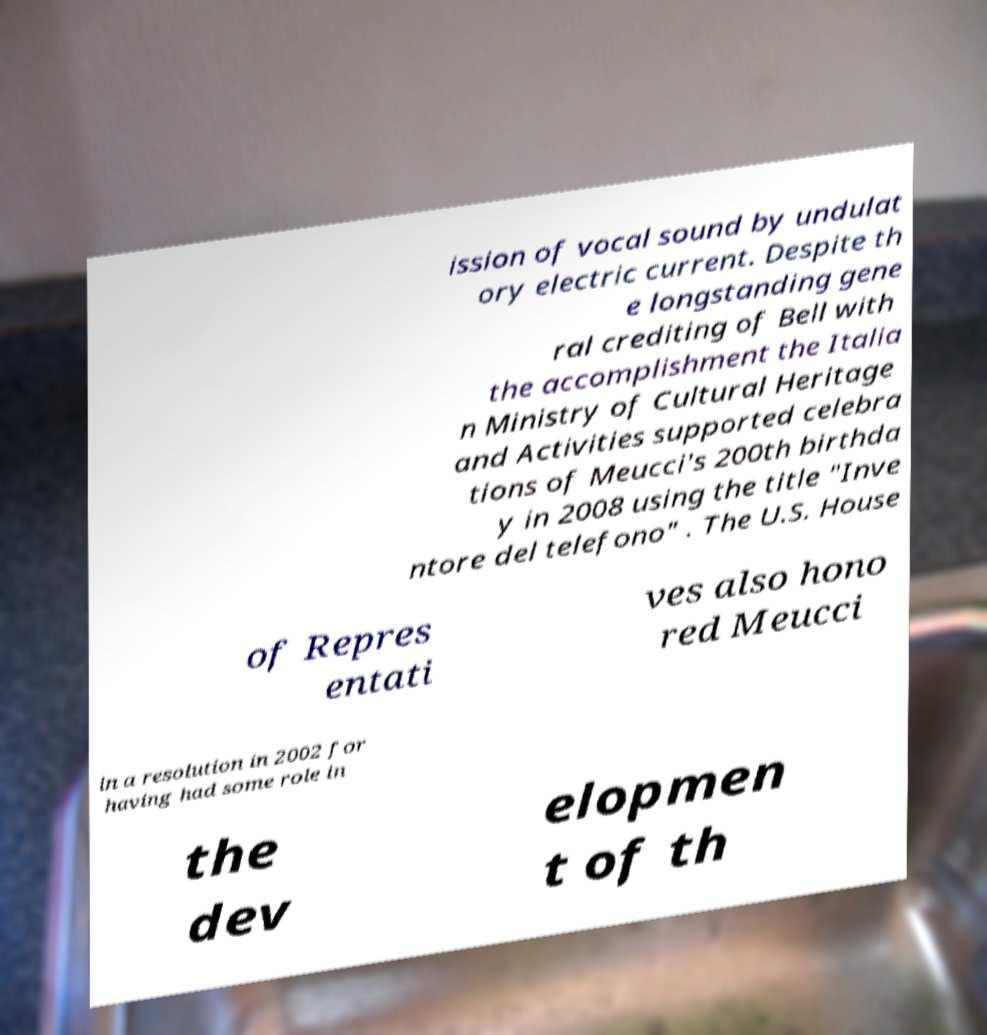There's text embedded in this image that I need extracted. Can you transcribe it verbatim? ission of vocal sound by undulat ory electric current. Despite th e longstanding gene ral crediting of Bell with the accomplishment the Italia n Ministry of Cultural Heritage and Activities supported celebra tions of Meucci's 200th birthda y in 2008 using the title "Inve ntore del telefono" . The U.S. House of Repres entati ves also hono red Meucci in a resolution in 2002 for having had some role in the dev elopmen t of th 